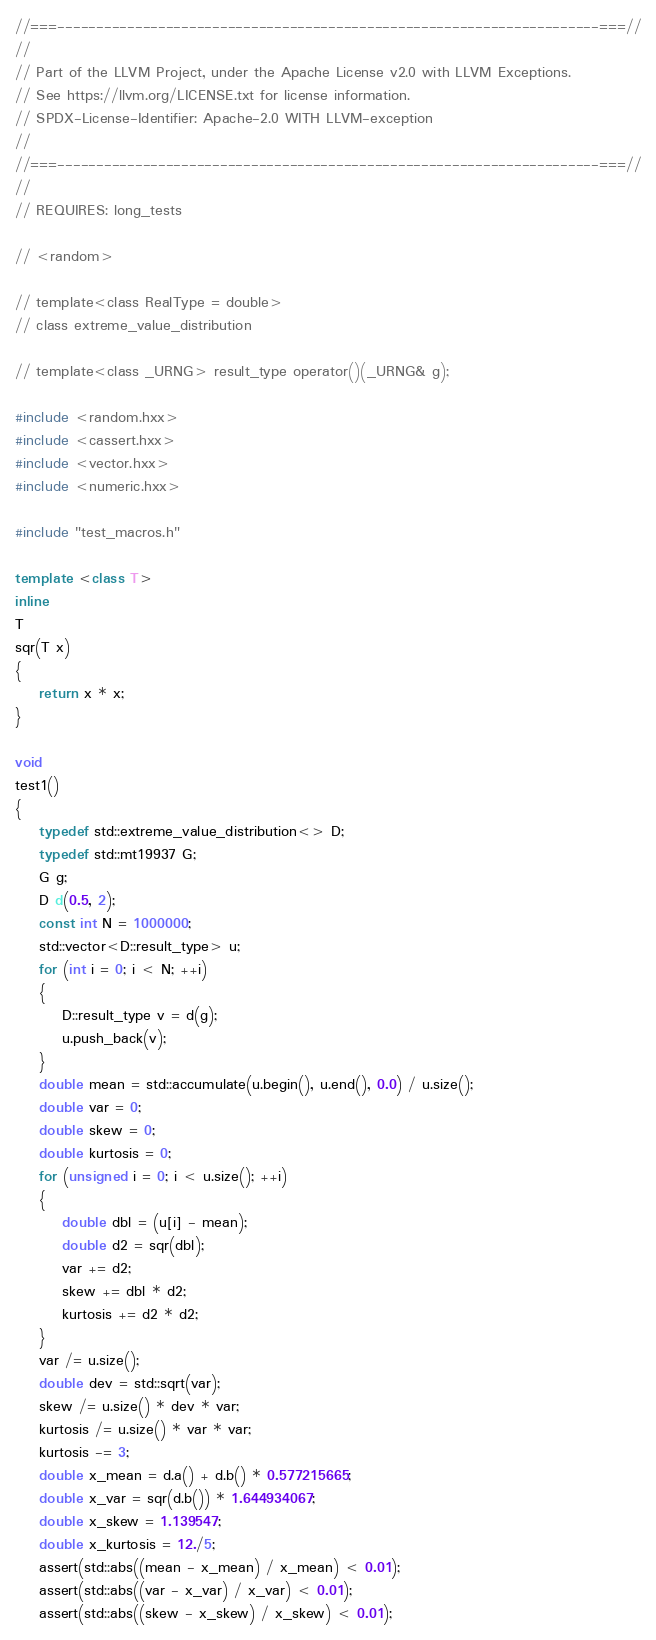<code> <loc_0><loc_0><loc_500><loc_500><_C++_>//===----------------------------------------------------------------------===//
//
// Part of the LLVM Project, under the Apache License v2.0 with LLVM Exceptions.
// See https://llvm.org/LICENSE.txt for license information.
// SPDX-License-Identifier: Apache-2.0 WITH LLVM-exception
//
//===----------------------------------------------------------------------===//
//
// REQUIRES: long_tests

// <random>

// template<class RealType = double>
// class extreme_value_distribution

// template<class _URNG> result_type operator()(_URNG& g);

#include <random.hxx>
#include <cassert.hxx>
#include <vector.hxx>
#include <numeric.hxx>

#include "test_macros.h"

template <class T>
inline
T
sqr(T x)
{
    return x * x;
}

void
test1()
{
    typedef std::extreme_value_distribution<> D;
    typedef std::mt19937 G;
    G g;
    D d(0.5, 2);
    const int N = 1000000;
    std::vector<D::result_type> u;
    for (int i = 0; i < N; ++i)
    {
        D::result_type v = d(g);
        u.push_back(v);
    }
    double mean = std::accumulate(u.begin(), u.end(), 0.0) / u.size();
    double var = 0;
    double skew = 0;
    double kurtosis = 0;
    for (unsigned i = 0; i < u.size(); ++i)
    {
        double dbl = (u[i] - mean);
        double d2 = sqr(dbl);
        var += d2;
        skew += dbl * d2;
        kurtosis += d2 * d2;
    }
    var /= u.size();
    double dev = std::sqrt(var);
    skew /= u.size() * dev * var;
    kurtosis /= u.size() * var * var;
    kurtosis -= 3;
    double x_mean = d.a() + d.b() * 0.577215665;
    double x_var = sqr(d.b()) * 1.644934067;
    double x_skew = 1.139547;
    double x_kurtosis = 12./5;
    assert(std::abs((mean - x_mean) / x_mean) < 0.01);
    assert(std::abs((var - x_var) / x_var) < 0.01);
    assert(std::abs((skew - x_skew) / x_skew) < 0.01);</code> 